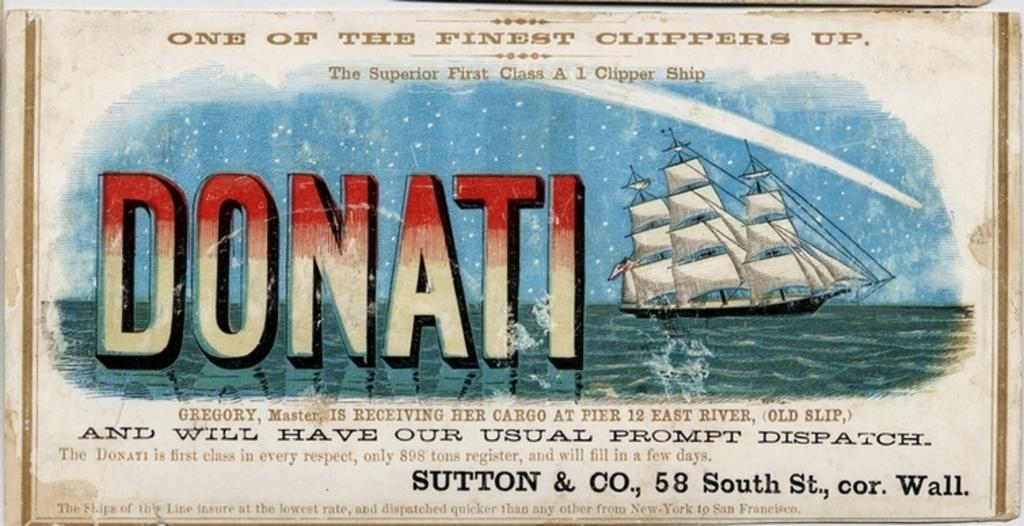What is the main subject of the image? There is a picture in the image. What can be seen on the picture? The picture has "PANATI" printed on it, and there is a ship in the picture. What is the setting of the picture? There is water in the picture, which suggests a maritime or coastal scene. Where is the swing located in the image? There is no swing present in the image. How many horses are depicted in the picture? There are no horses depicted in the picture; it features a ship and water. 